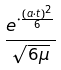Convert formula to latex. <formula><loc_0><loc_0><loc_500><loc_500>\frac { e ^ { \cdot \frac { ( a \cdot t ) ^ { 2 } } { 6 } } } { \sqrt { 6 \mu } }</formula> 